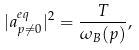<formula> <loc_0><loc_0><loc_500><loc_500>| a ^ { e q } _ { { p } \ne { 0 } } | ^ { 2 } = \frac { T } { \omega _ { B } ( p ) } ,</formula> 